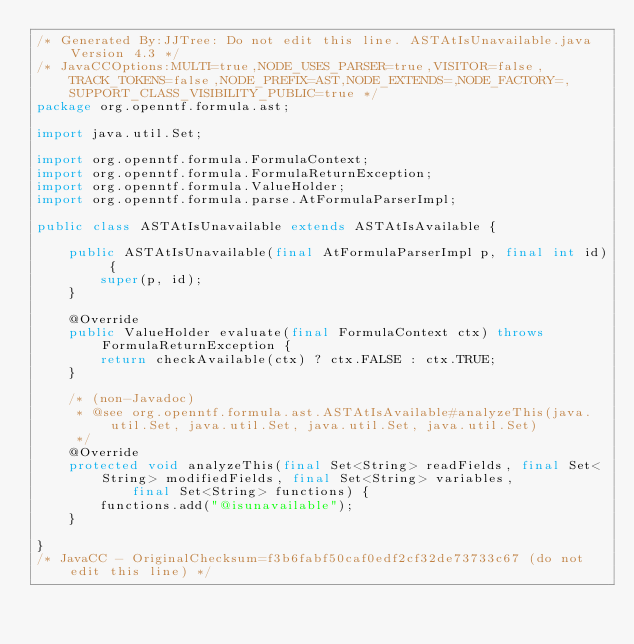Convert code to text. <code><loc_0><loc_0><loc_500><loc_500><_Java_>/* Generated By:JJTree: Do not edit this line. ASTAtIsUnavailable.java Version 4.3 */
/* JavaCCOptions:MULTI=true,NODE_USES_PARSER=true,VISITOR=false,TRACK_TOKENS=false,NODE_PREFIX=AST,NODE_EXTENDS=,NODE_FACTORY=,SUPPORT_CLASS_VISIBILITY_PUBLIC=true */
package org.openntf.formula.ast;

import java.util.Set;

import org.openntf.formula.FormulaContext;
import org.openntf.formula.FormulaReturnException;
import org.openntf.formula.ValueHolder;
import org.openntf.formula.parse.AtFormulaParserImpl;

public class ASTAtIsUnavailable extends ASTAtIsAvailable {

	public ASTAtIsUnavailable(final AtFormulaParserImpl p, final int id) {
		super(p, id);
	}

	@Override
	public ValueHolder evaluate(final FormulaContext ctx) throws FormulaReturnException {
		return checkAvailable(ctx) ? ctx.FALSE : ctx.TRUE;
	}

	/* (non-Javadoc)
	 * @see org.openntf.formula.ast.ASTAtIsAvailable#analyzeThis(java.util.Set, java.util.Set, java.util.Set, java.util.Set)
	 */
	@Override
	protected void analyzeThis(final Set<String> readFields, final Set<String> modifiedFields, final Set<String> variables,
			final Set<String> functions) {
		functions.add("@isunavailable");
	}

}
/* JavaCC - OriginalChecksum=f3b6fabf50caf0edf2cf32de73733c67 (do not edit this line) */
</code> 